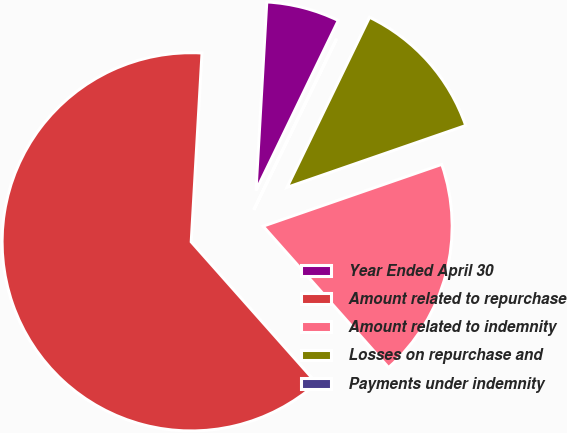<chart> <loc_0><loc_0><loc_500><loc_500><pie_chart><fcel>Year Ended April 30<fcel>Amount related to repurchase<fcel>Amount related to indemnity<fcel>Losses on repurchase and<fcel>Payments under indemnity<nl><fcel>6.26%<fcel>62.46%<fcel>18.75%<fcel>12.51%<fcel>0.02%<nl></chart> 